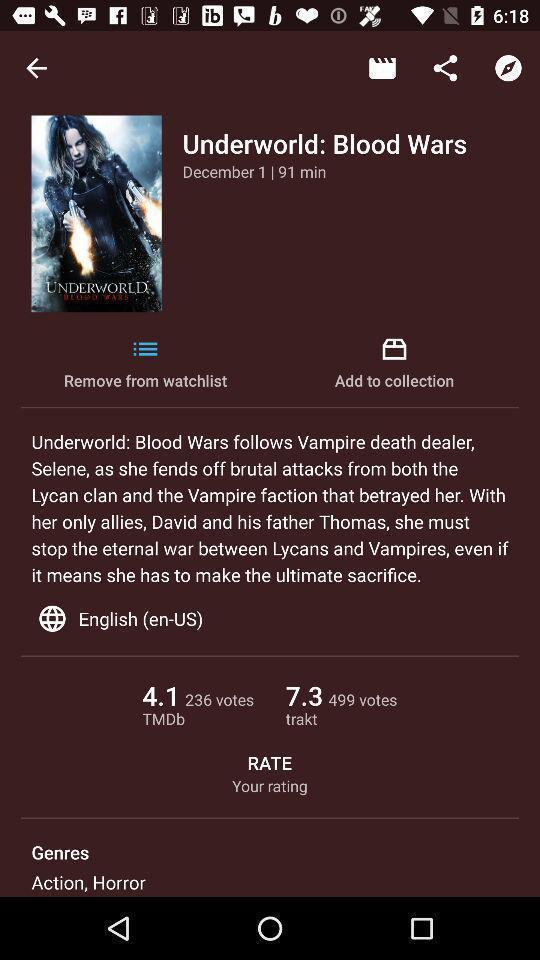Summarize the information in this screenshot. Page displaying the information of a movie. 